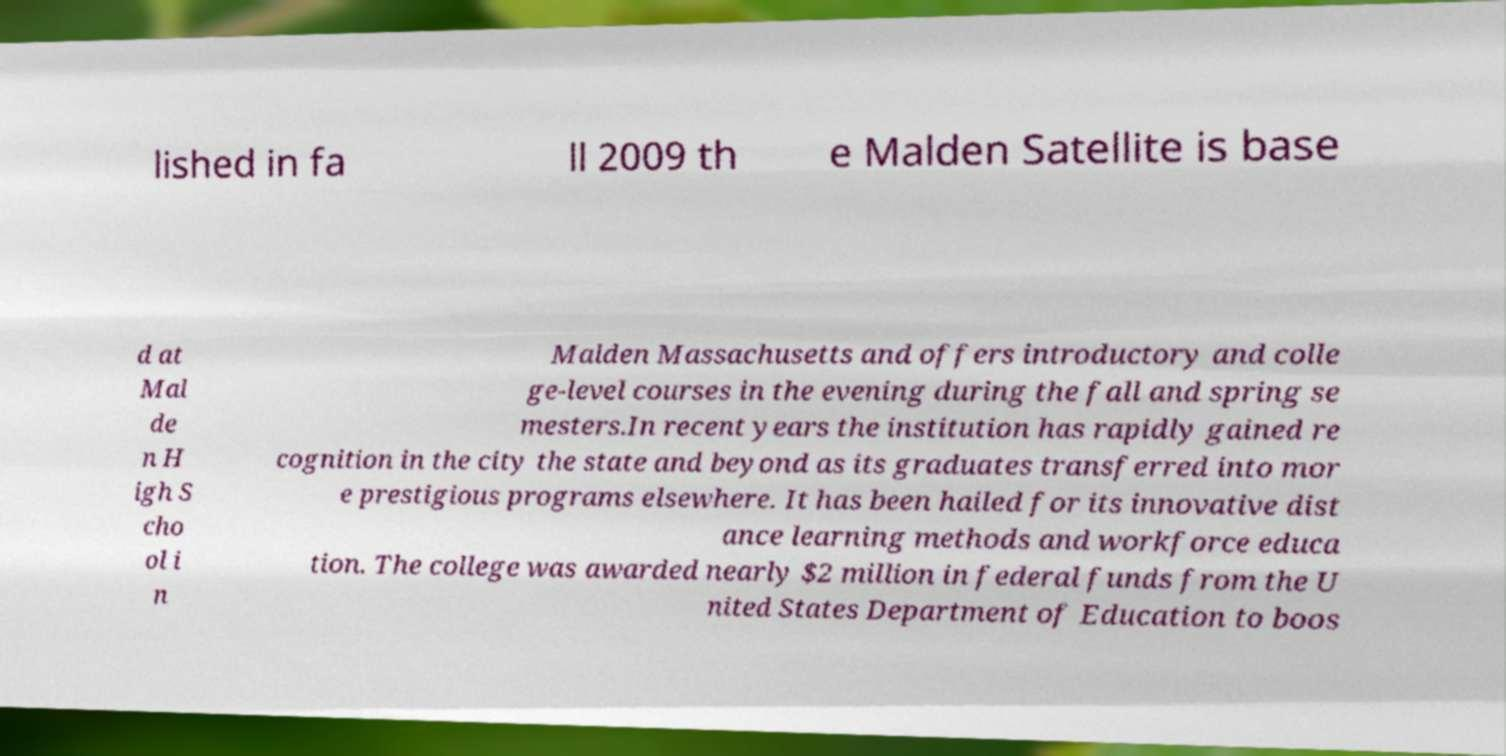Can you accurately transcribe the text from the provided image for me? lished in fa ll 2009 th e Malden Satellite is base d at Mal de n H igh S cho ol i n Malden Massachusetts and offers introductory and colle ge-level courses in the evening during the fall and spring se mesters.In recent years the institution has rapidly gained re cognition in the city the state and beyond as its graduates transferred into mor e prestigious programs elsewhere. It has been hailed for its innovative dist ance learning methods and workforce educa tion. The college was awarded nearly $2 million in federal funds from the U nited States Department of Education to boos 